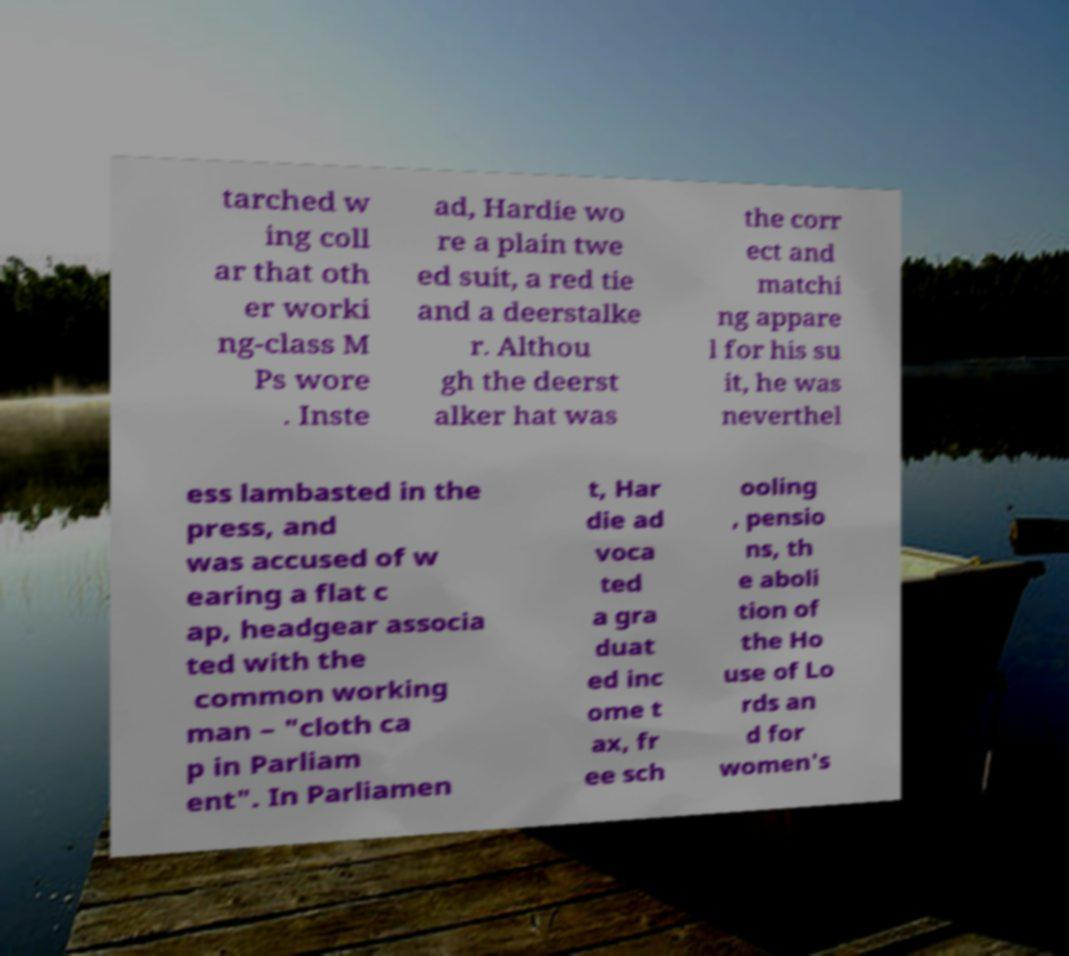I need the written content from this picture converted into text. Can you do that? tarched w ing coll ar that oth er worki ng-class M Ps wore . Inste ad, Hardie wo re a plain twe ed suit, a red tie and a deerstalke r. Althou gh the deerst alker hat was the corr ect and matchi ng appare l for his su it, he was neverthel ess lambasted in the press, and was accused of w earing a flat c ap, headgear associa ted with the common working man – "cloth ca p in Parliam ent". In Parliamen t, Har die ad voca ted a gra duat ed inc ome t ax, fr ee sch ooling , pensio ns, th e aboli tion of the Ho use of Lo rds an d for women's 